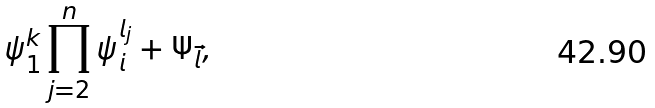<formula> <loc_0><loc_0><loc_500><loc_500>\psi _ { 1 } ^ { k } \prod _ { j = 2 } ^ { n } \psi _ { i } ^ { l _ { j } } + \Psi _ { \vec { l } } ,</formula> 